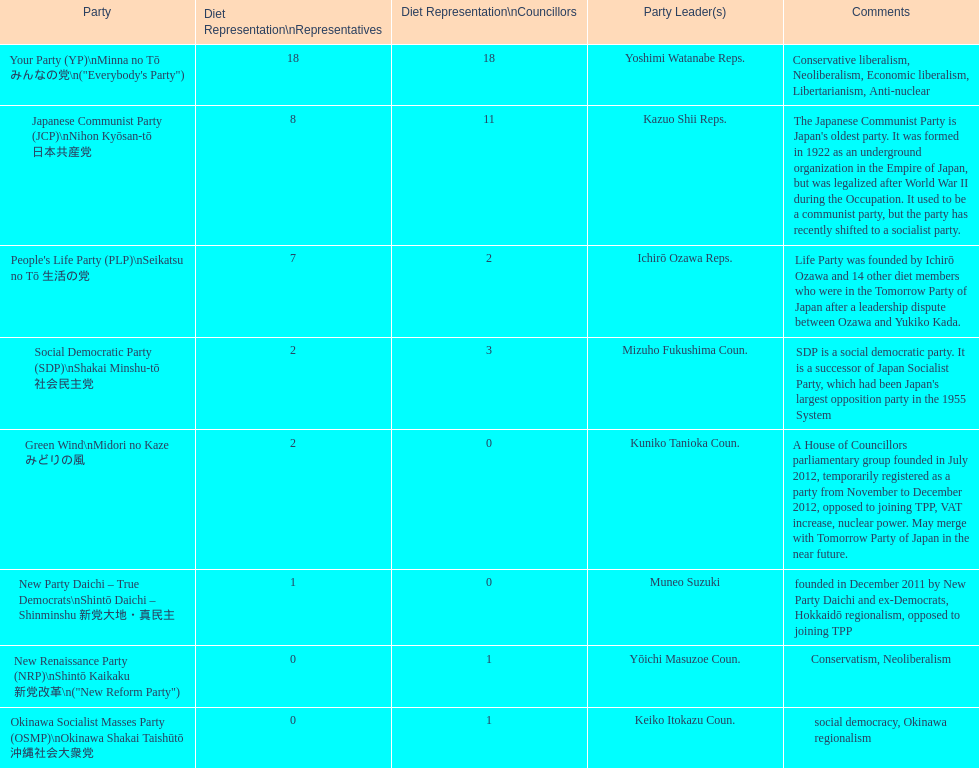According to this table, which party is japan's oldest political party? Japanese Communist Party (JCP) Nihon Kyōsan-tō 日本共産党. 